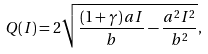<formula> <loc_0><loc_0><loc_500><loc_500>Q ( I ) = 2 \sqrt { \frac { ( 1 + \gamma ) \, a I } { b } - \frac { a ^ { 2 } I ^ { 2 } } { b ^ { 2 } } } ,</formula> 